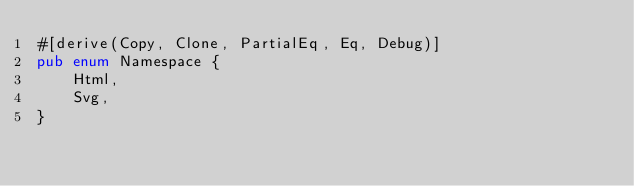<code> <loc_0><loc_0><loc_500><loc_500><_Rust_>#[derive(Copy, Clone, PartialEq, Eq, Debug)]
pub enum Namespace {
    Html,
    Svg,
}
</code> 